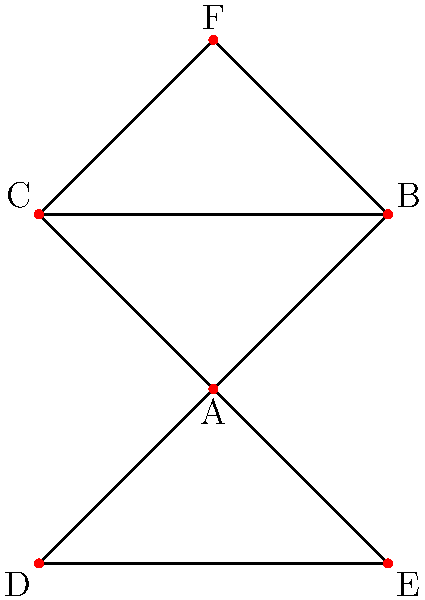In the graph representing characters from Julie Morstad's illustrated books, what is the minimum number of characters that need to be removed to disconnect character F from character D? To solve this problem, we need to analyze the connectivity between characters F and D in the given graph. Let's follow these steps:

1. Identify the paths between F and D:
   - Path 1: F → B → A → D
   - Path 2: F → C → A → D

2. Observe that both paths pass through character A.

3. If we remove character A, there is no way to reach D from F.

4. Check if removing any other single character would disconnect F from D:
   - Removing B or C alone doesn't disconnect F from D
   - Removing D itself is not considered as we want to disconnect F from D
   - Removing E doesn't affect the paths between F and D

5. Conclude that removing just one character (A) is sufficient to disconnect F from D.

Therefore, the minimum number of characters that need to be removed to disconnect F from D is 1.
Answer: 1 